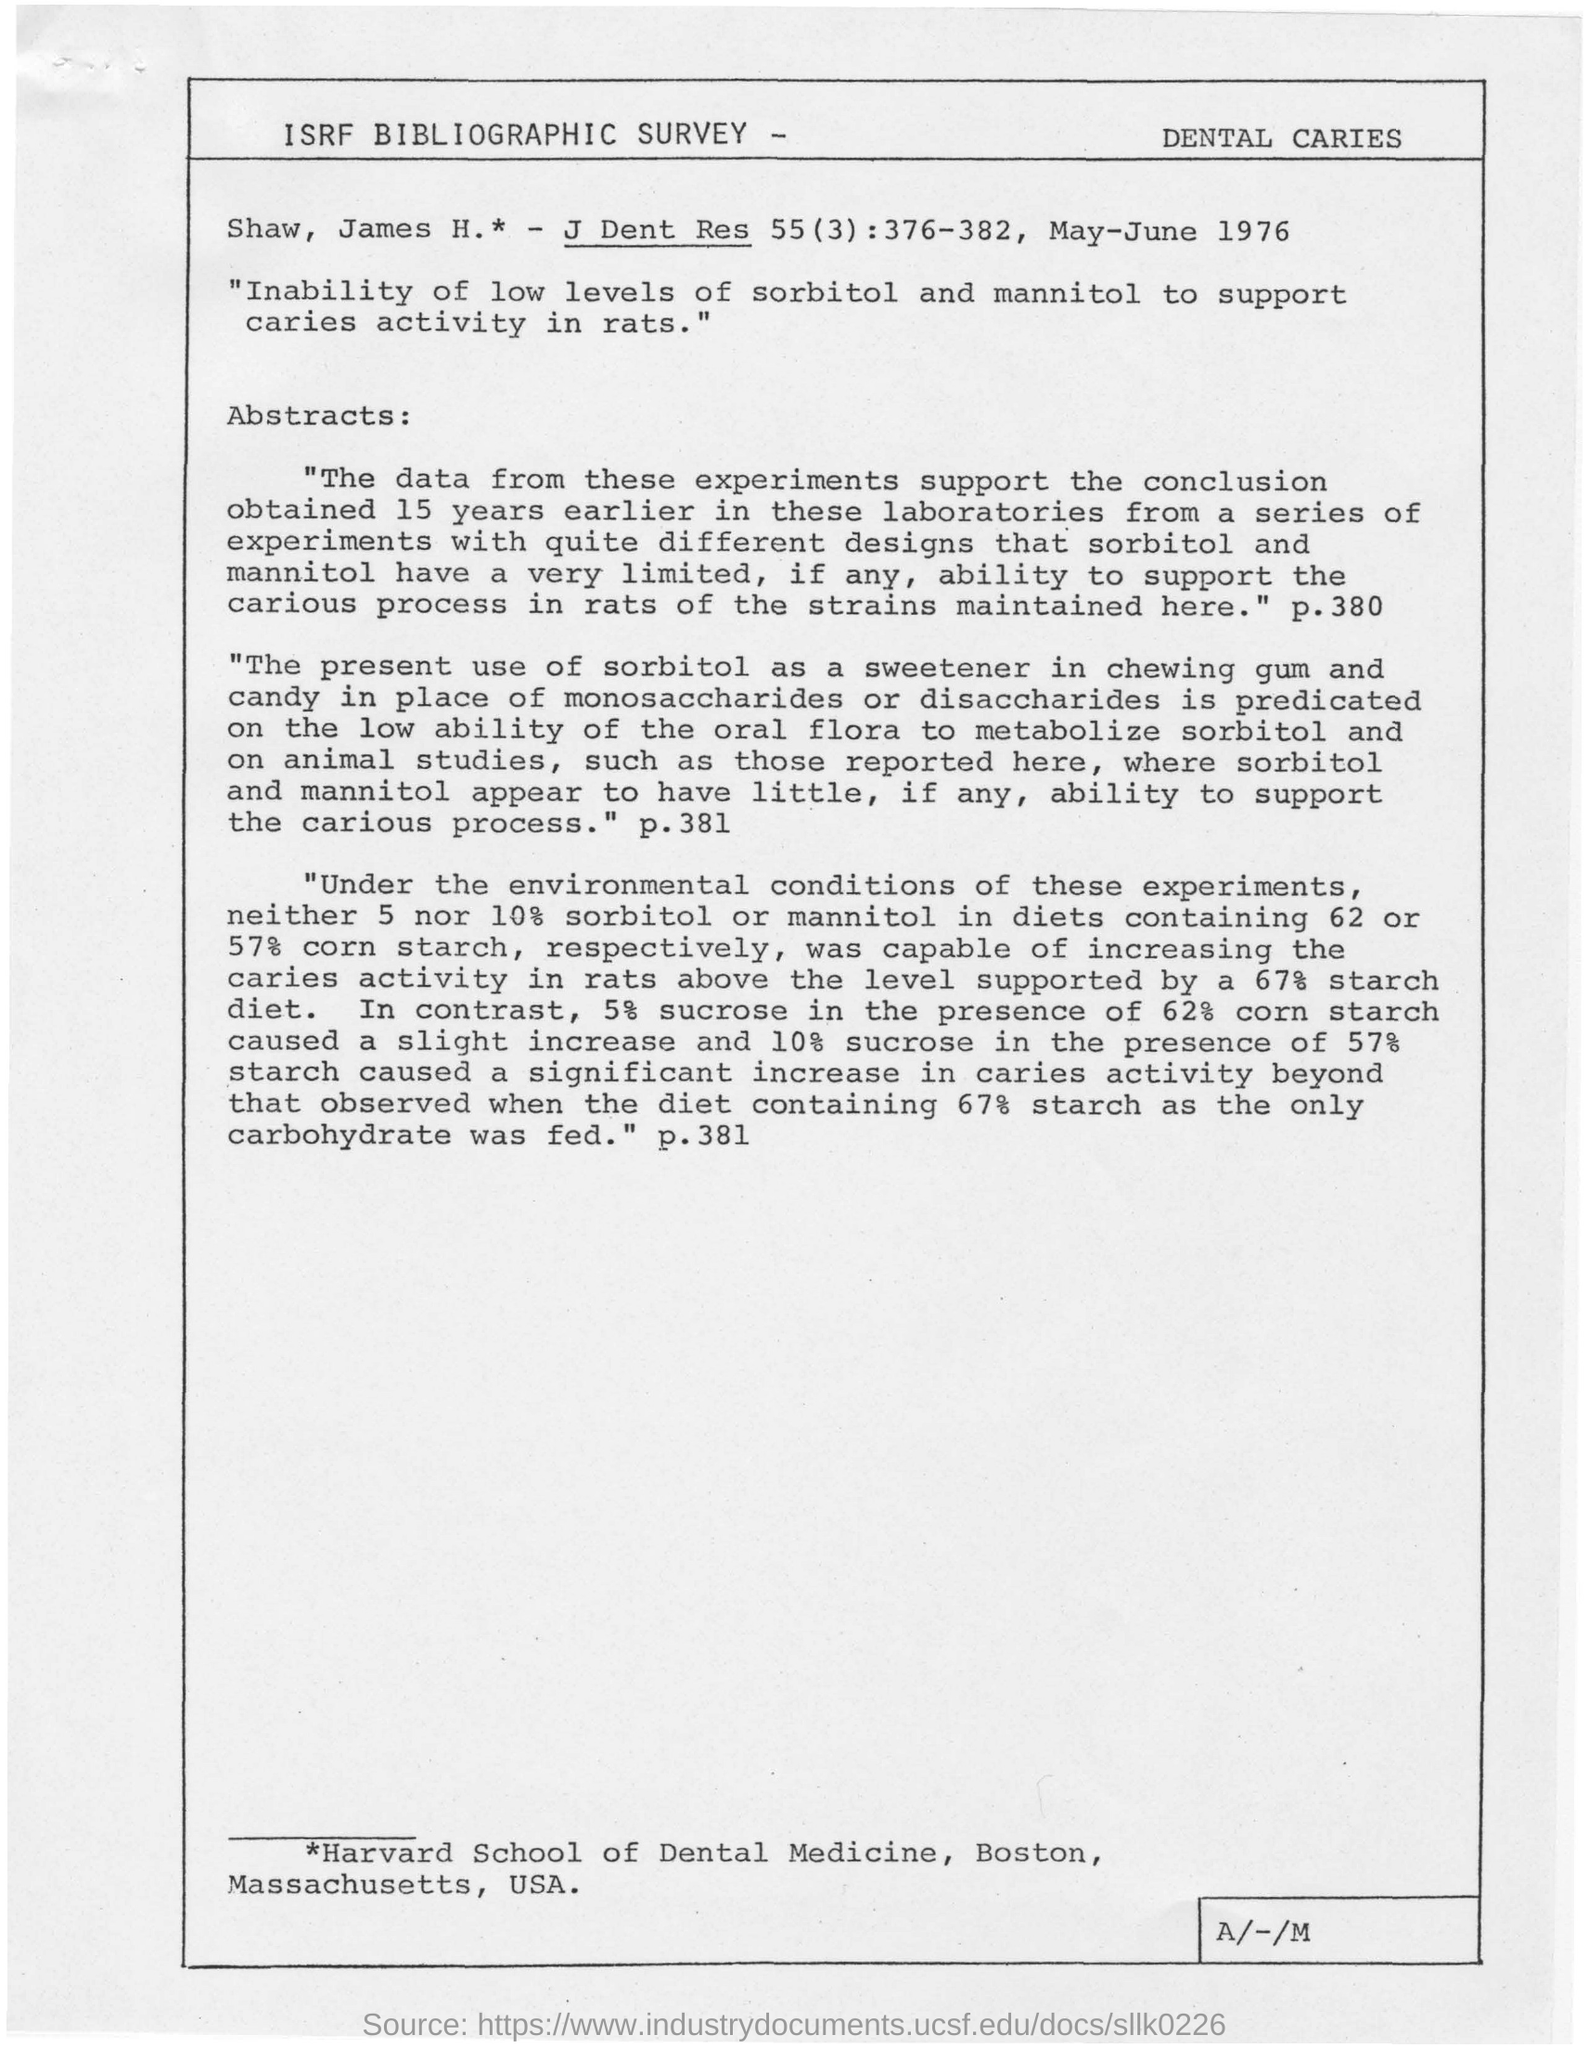Point out several critical features in this image. The use of rats has been established as a reliable method for determining the ability to metabolize low levels of sorbitol and mannitol. The institution mentioned in the footer is Harvard School of Dental Medicine, located in Boston, Massachusetts, USA. 